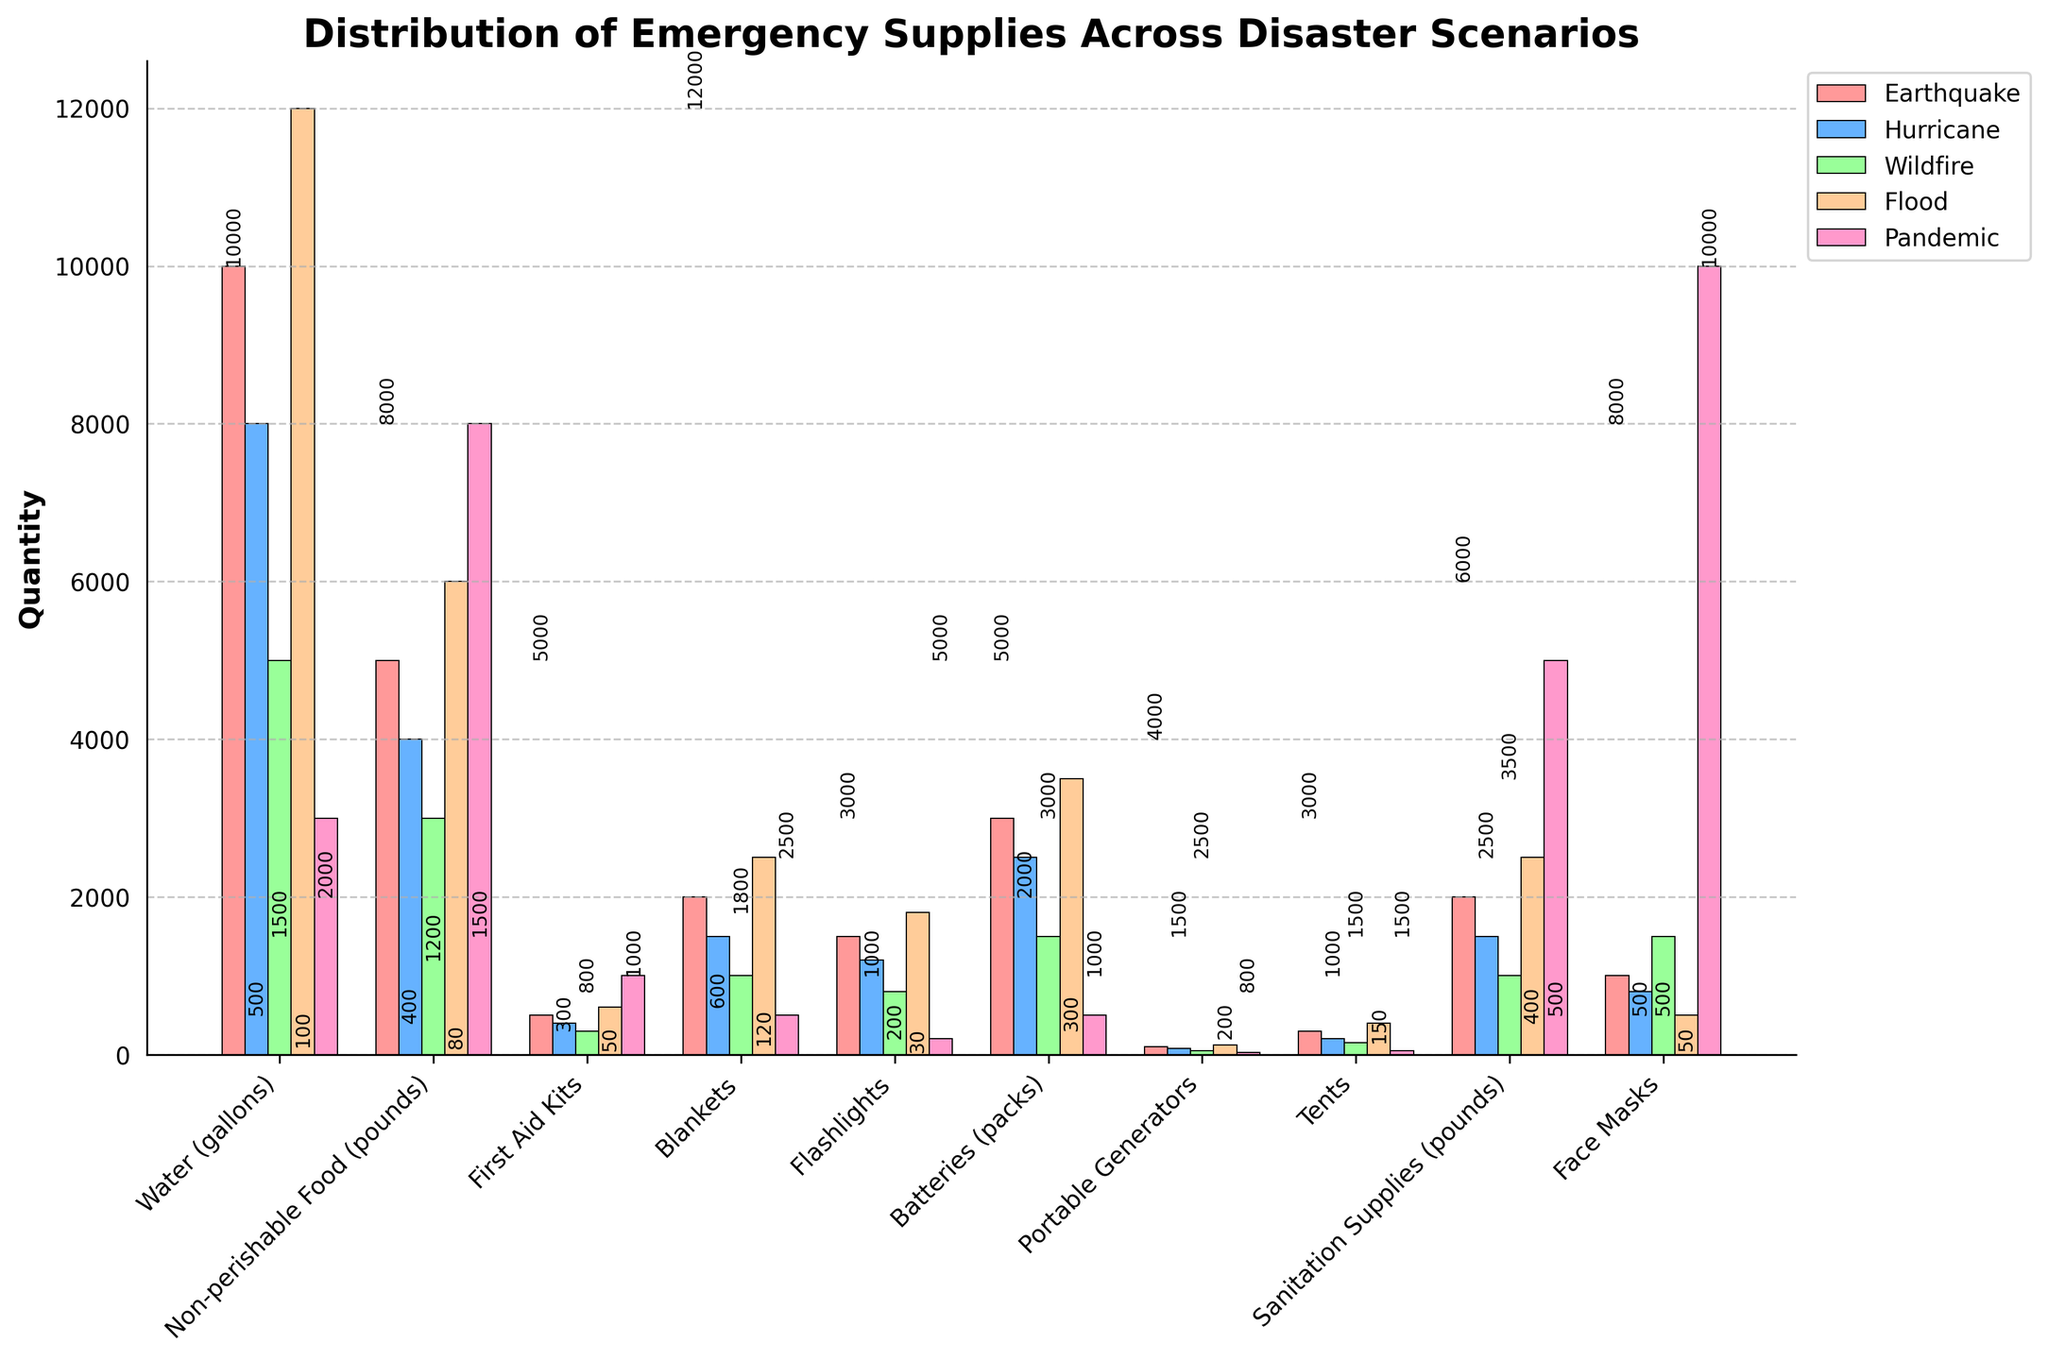What is the title of the figure? The title of the figure is shown at the top and represents the main theme of the plot. Here, it indicates what the distribution is about.
Answer: Distribution of Emergency Supplies Across Disaster Scenarios What are the different emergency supply types listed on the x-axis? The x-axis has labels for different supply types. Rotating the labels can help read them easily.
Answer: Water, Non-perishable Food, First Aid Kits, Blankets, Flashlights, Batteries, Portable Generators, Tents, Sanitation Supplies, Face Masks Which disaster scenario requires the most water? By comparing the height of the bars for water (gallons) across the disaster scenarios, we can determine which has the highest requirement.
Answer: Flood How many disaster scenarios are compared in the plot? The number of scenarios can be found by identifying the number of clustered bars of different colors related to each supply type.
Answer: 5 For which supply type is the demand highest during a pandemic? Look at each supply type and find the bar representing the pandemic with the greatest height.
Answer: Face Masks Compare the quantities of first aid kits required for an earthquake and a wildfire. Which is greater? Examine the heights of the bars specifically for first aid kits under both scenarios to determine which is greater.
Answer: Earthquake Which disaster scenario shows the least demand for portable generators? Identify the shortest bar for portable generators among the different scenarios.
Answer: Pandemic Calculate the total quantity of batteries required for all disaster scenarios combined. Sum the bar heights for batteries (packs) across each disaster scenario.
Answer: 3000 + 2500 + 1500 + 3500 + 500 = 11000 What supply type has an equal quantity requirement for both water during a hurricane and blankets during a flood? Find the bar for water during a hurricane and see if it matches any other bar's height in the plot.
Answer: Non-perishable Food during an earthquake Which disaster scenario has the highest demand for sanitation supplies? Compare the heights of bars for sanitation supplies across all the disaster scenarios.
Answer: Pandemic 